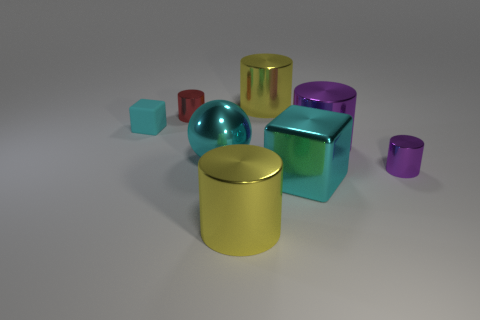Is there anything else that is made of the same material as the tiny cyan cube?
Provide a succinct answer. No. There is a cyan block that is the same size as the red object; what material is it?
Your answer should be very brief. Rubber. Is the material of the tiny object to the right of the tiny red cylinder the same as the small cylinder that is on the left side of the metal cube?
Offer a terse response. Yes. What shape is the purple shiny thing that is the same size as the red metallic object?
Your response must be concise. Cylinder. How many other objects are there of the same color as the big metallic sphere?
Your answer should be compact. 2. There is a big thing that is behind the small red cylinder; what color is it?
Your answer should be very brief. Yellow. What number of other things are the same material as the small purple cylinder?
Offer a terse response. 6. Are there more metallic blocks that are on the left side of the large purple metallic cylinder than red cylinders that are to the left of the rubber object?
Your answer should be very brief. Yes. What number of tiny purple cylinders are in front of the large metal ball?
Offer a terse response. 1. Is the material of the small cyan thing the same as the large purple thing to the right of the red cylinder?
Give a very brief answer. No. 